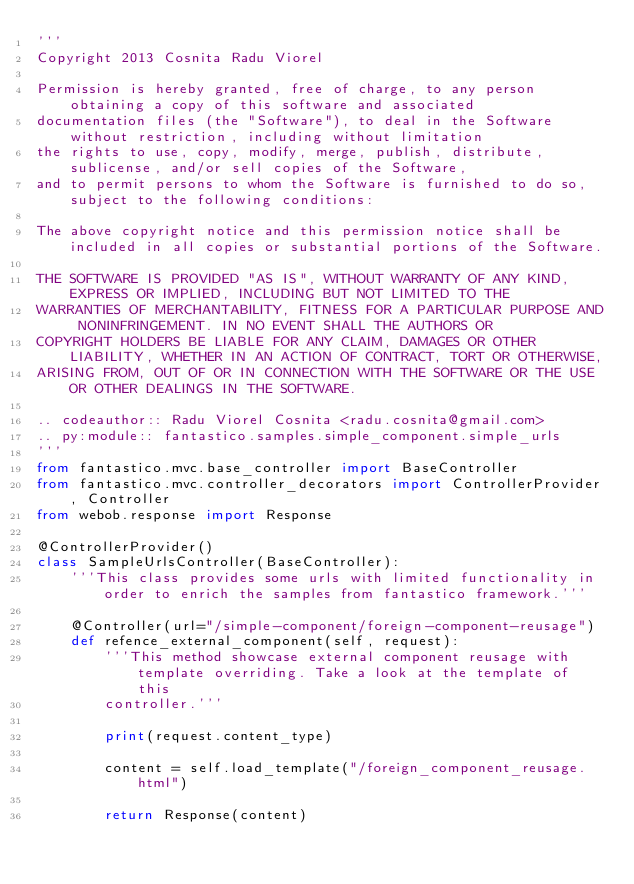<code> <loc_0><loc_0><loc_500><loc_500><_Python_>'''
Copyright 2013 Cosnita Radu Viorel

Permission is hereby granted, free of charge, to any person obtaining a copy of this software and associated
documentation files (the "Software"), to deal in the Software without restriction, including without limitation
the rights to use, copy, modify, merge, publish, distribute, sublicense, and/or sell copies of the Software,
and to permit persons to whom the Software is furnished to do so, subject to the following conditions:

The above copyright notice and this permission notice shall be included in all copies or substantial portions of the Software.

THE SOFTWARE IS PROVIDED "AS IS", WITHOUT WARRANTY OF ANY KIND, EXPRESS OR IMPLIED, INCLUDING BUT NOT LIMITED TO THE
WARRANTIES OF MERCHANTABILITY, FITNESS FOR A PARTICULAR PURPOSE AND NONINFRINGEMENT. IN NO EVENT SHALL THE AUTHORS OR
COPYRIGHT HOLDERS BE LIABLE FOR ANY CLAIM, DAMAGES OR OTHER LIABILITY, WHETHER IN AN ACTION OF CONTRACT, TORT OR OTHERWISE,
ARISING FROM, OUT OF OR IN CONNECTION WITH THE SOFTWARE OR THE USE OR OTHER DEALINGS IN THE SOFTWARE.

.. codeauthor:: Radu Viorel Cosnita <radu.cosnita@gmail.com>
.. py:module:: fantastico.samples.simple_component.simple_urls
'''
from fantastico.mvc.base_controller import BaseController
from fantastico.mvc.controller_decorators import ControllerProvider, Controller
from webob.response import Response

@ControllerProvider()
class SampleUrlsController(BaseController):
    '''This class provides some urls with limited functionality in order to enrich the samples from fantastico framework.'''

    @Controller(url="/simple-component/foreign-component-reusage")
    def refence_external_component(self, request):
        '''This method showcase external component reusage with template overriding. Take a look at the template of this
        controller.'''

        print(request.content_type)

        content = self.load_template("/foreign_component_reusage.html")

        return Response(content)
</code> 